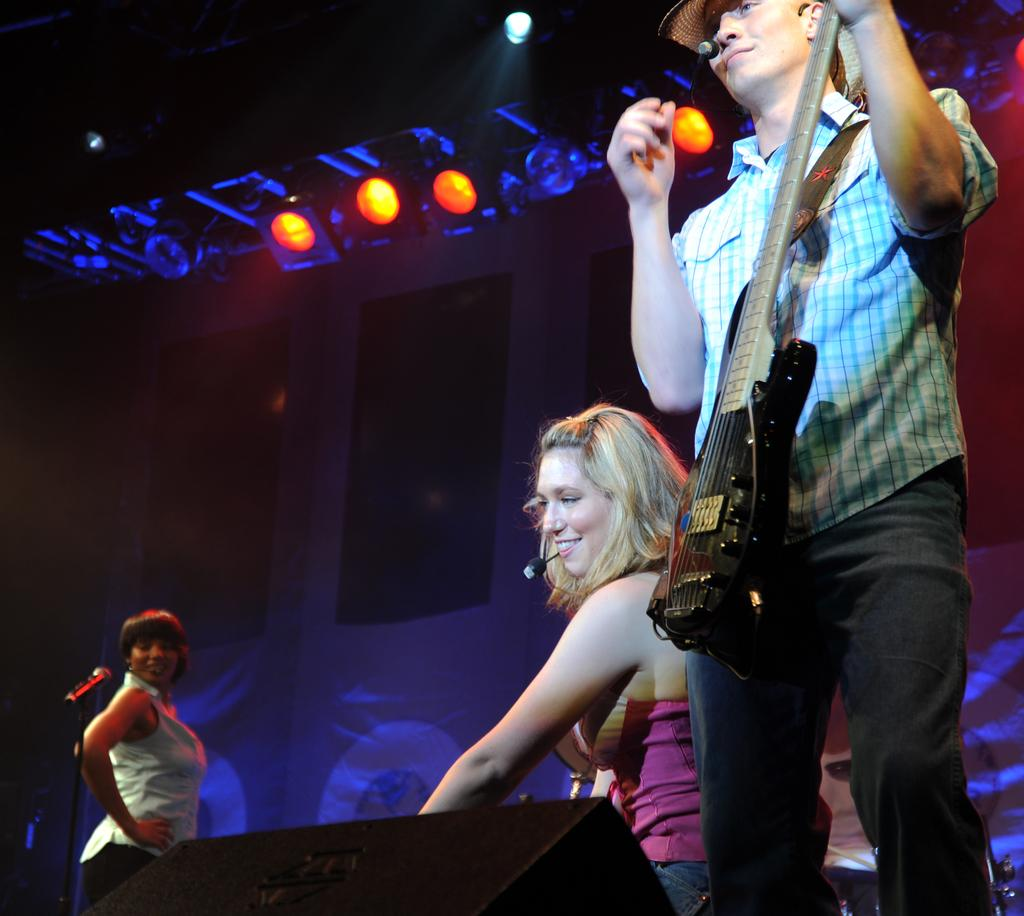What is the man in the image doing? The man is standing and playing a guitar. What is the position of the first woman in the image? The first woman is sitting. What is the second woman doing in the image? The second woman is standing near a microphone. What can be seen in the background of the image? There is a screen and lights in the background. What type of nose can be seen on the guitar in the image? There is no nose present on the guitar in the image; it is a musical instrument. 